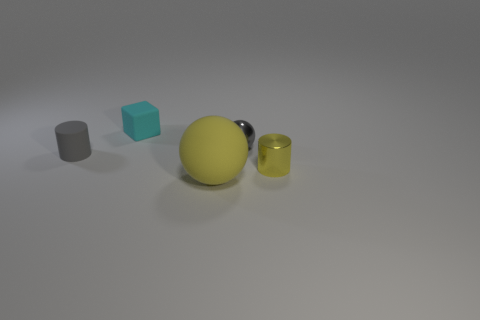Add 4 big green spheres. How many objects exist? 9 Subtract all yellow cylinders. How many cylinders are left? 1 Subtract all cubes. How many objects are left? 4 Subtract all large objects. Subtract all small purple shiny cylinders. How many objects are left? 4 Add 1 gray spheres. How many gray spheres are left? 2 Add 2 tiny gray objects. How many tiny gray objects exist? 4 Subtract 0 gray blocks. How many objects are left? 5 